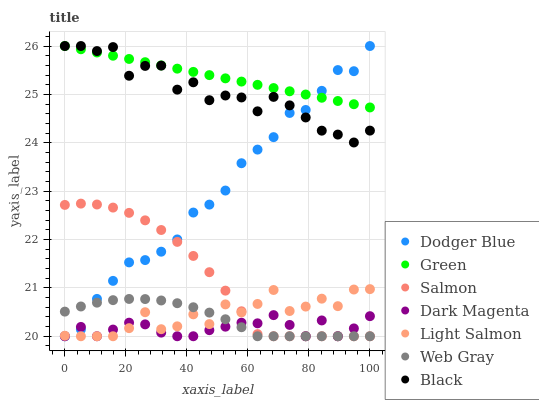Does Dark Magenta have the minimum area under the curve?
Answer yes or no. Yes. Does Green have the maximum area under the curve?
Answer yes or no. Yes. Does Web Gray have the minimum area under the curve?
Answer yes or no. No. Does Web Gray have the maximum area under the curve?
Answer yes or no. No. Is Green the smoothest?
Answer yes or no. Yes. Is Black the roughest?
Answer yes or no. Yes. Is Web Gray the smoothest?
Answer yes or no. No. Is Web Gray the roughest?
Answer yes or no. No. Does Light Salmon have the lowest value?
Answer yes or no. Yes. Does Green have the lowest value?
Answer yes or no. No. Does Dodger Blue have the highest value?
Answer yes or no. Yes. Does Web Gray have the highest value?
Answer yes or no. No. Is Web Gray less than Green?
Answer yes or no. Yes. Is Green greater than Web Gray?
Answer yes or no. Yes. Does Light Salmon intersect Salmon?
Answer yes or no. Yes. Is Light Salmon less than Salmon?
Answer yes or no. No. Is Light Salmon greater than Salmon?
Answer yes or no. No. Does Web Gray intersect Green?
Answer yes or no. No. 